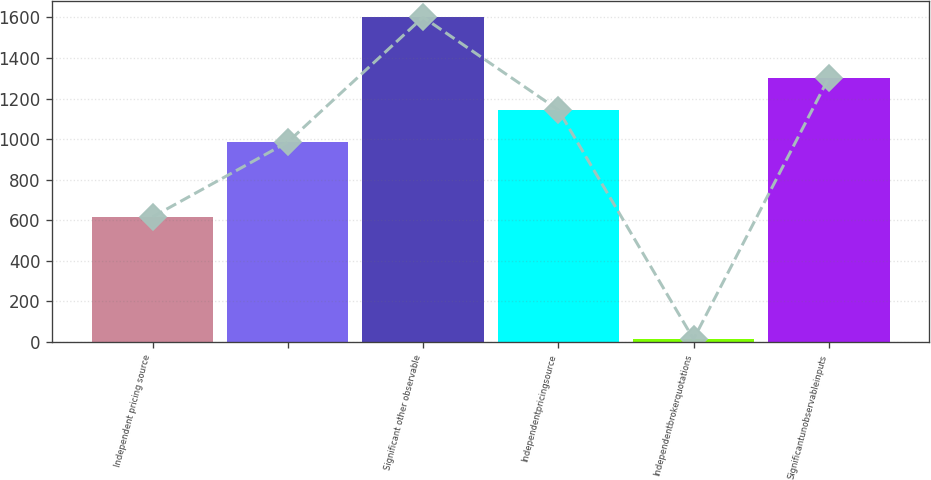<chart> <loc_0><loc_0><loc_500><loc_500><bar_chart><fcel>Independent pricing source<fcel>Unnamed: 1<fcel>Significant other observable<fcel>Independentpricingsource<fcel>Independentbrokerquotations<fcel>Significantunobservableinputs<nl><fcel>616<fcel>985<fcel>1601<fcel>1143.8<fcel>13<fcel>1302.6<nl></chart> 